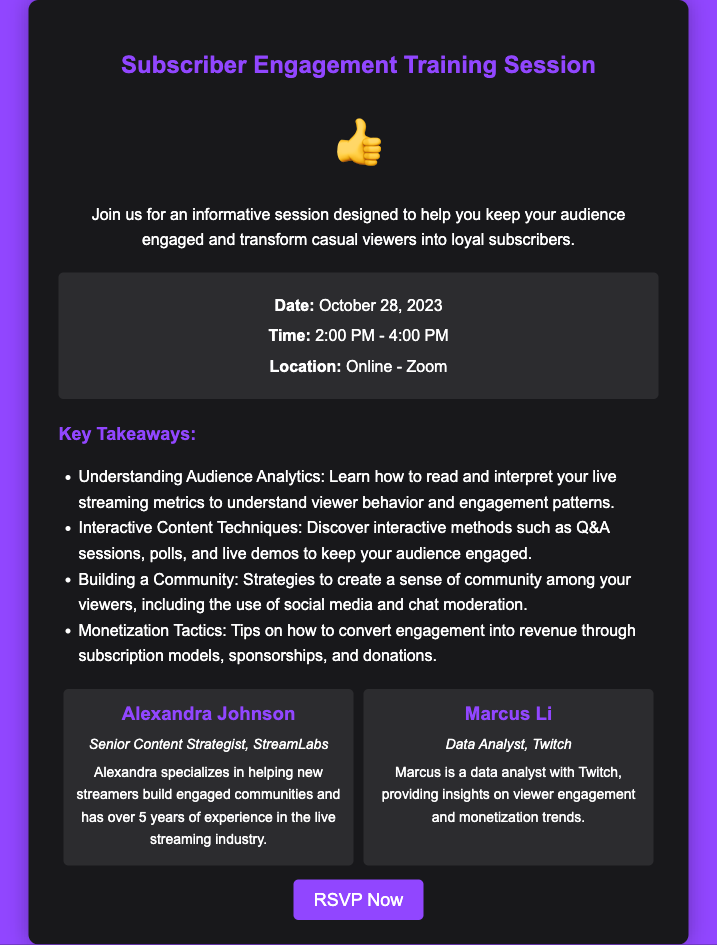What is the date of the training session? The document states that the training session is on October 28, 2023.
Answer: October 28, 2023 What time does the training session start? The document provides the time as 2:00 PM to 4:00 PM.
Answer: 2:00 PM Who is one of the speakers at the event? The document lists Alexandra Johnson and Marcus Li as speakers.
Answer: Alexandra Johnson What is a key takeaway from the session? The document mentions several key takeaways, one of which is understanding audience analytics.
Answer: Understanding Audience Analytics What is the location of the training session? Information in the document states that the location is Online - Zoom.
Answer: Online - Zoom How long is the training session? The session runs from 2:00 PM to 4:00 PM, which is 2 hours long.
Answer: 2 hours What is the purpose of the training session? The document describes the purpose as teaching how to keep the audience engaged and encourage them to be loyal subscribers.
Answer: Keep your audience engaged What does the thumbs-up icon signify? The thumbs-up icon typically signifies approval or something positive related to the training session.
Answer: Approval How can one RSVP for the event? The document includes a link labeled "RSVP Now" for participants to register.
Answer: RSVP Now 